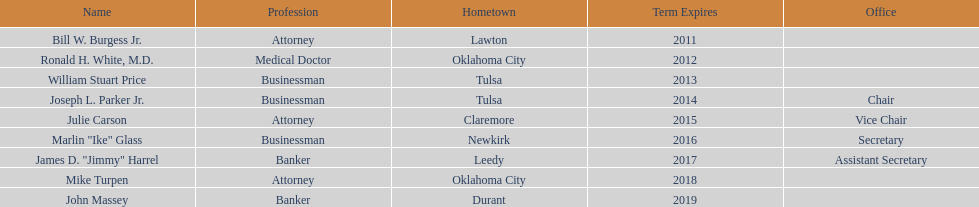What is the number of present state regents with an official office title mentioned? 4. 